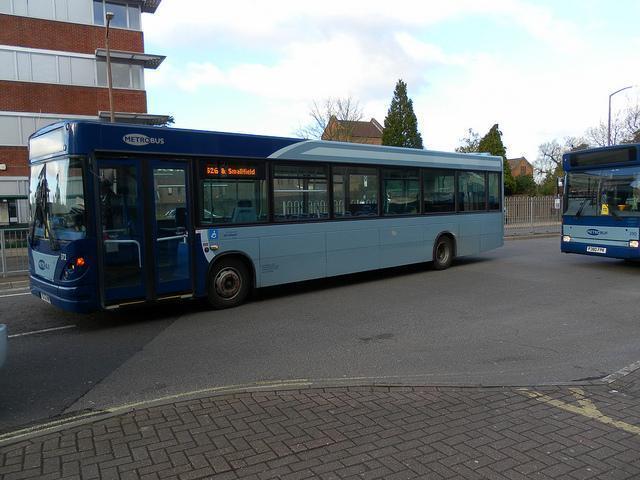How many doors does the bus have?
Give a very brief answer. 2. How many trash container are there?
Give a very brief answer. 0. How many buses are there?
Give a very brief answer. 2. How many bikes?
Give a very brief answer. 0. How many buses are visible?
Give a very brief answer. 2. How many person is wearing orange color t-shirt?
Give a very brief answer. 0. 